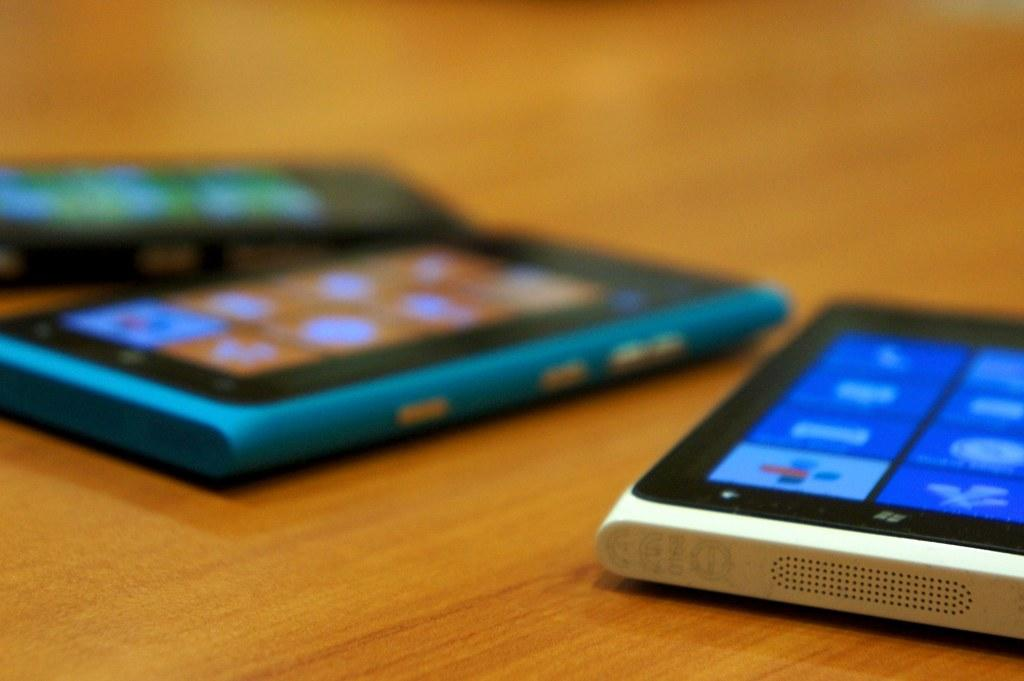What objects are present in the image? There are mobiles in the image. Can you describe the background of the image? The background of the image is blurred. What type of jelly can be seen in the image? There is no jelly present in the image. How many baskets are visible in the image? There are no baskets present in the image. 